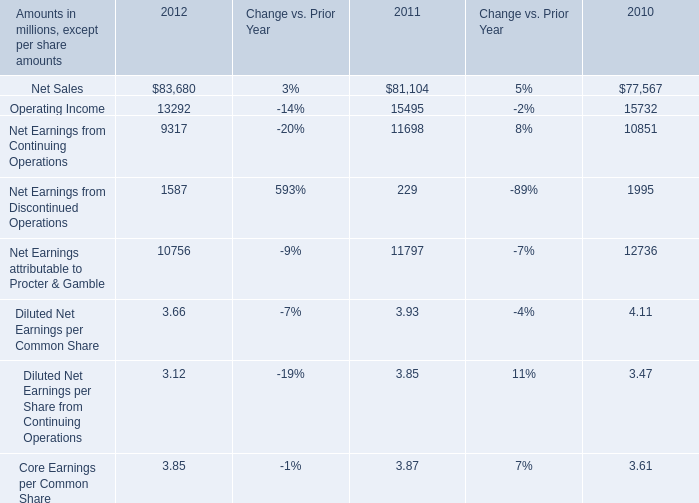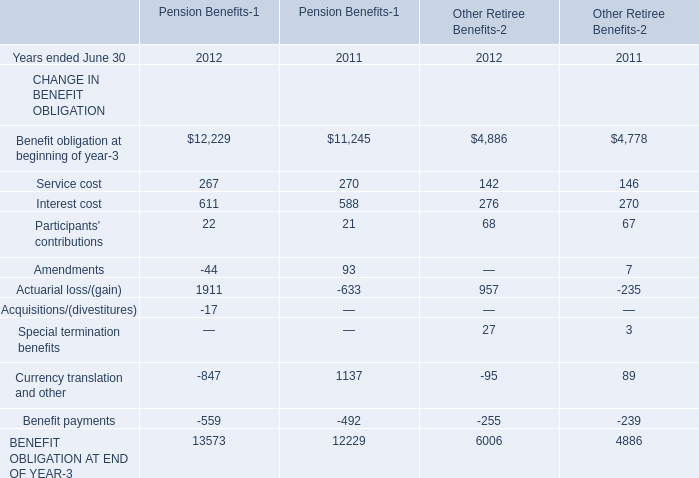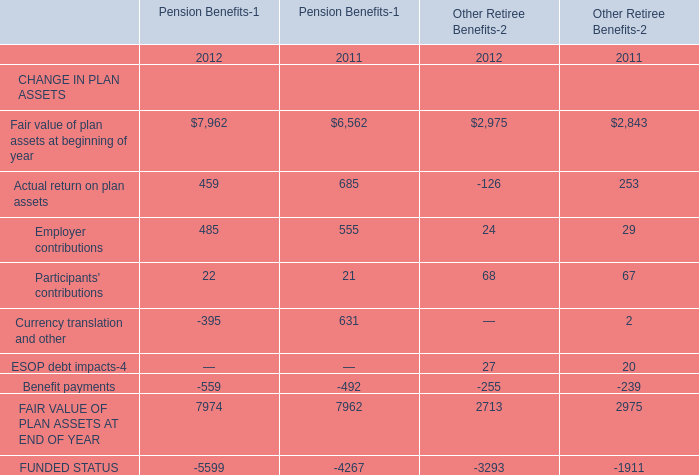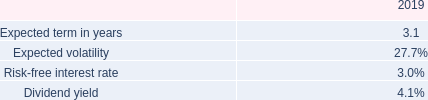What was the average value of Service cost, Interest cost, Participants' contributions for pension benefits in 2011 ? 
Computations: (((270 + 588) + 21) / 3)
Answer: 293.0. 